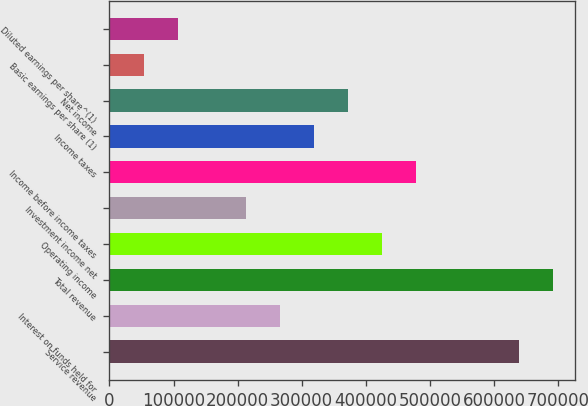<chart> <loc_0><loc_0><loc_500><loc_500><bar_chart><fcel>Service revenue<fcel>Interest on funds held for<fcel>Total revenue<fcel>Operating income<fcel>Investment income net<fcel>Income before income taxes<fcel>Income taxes<fcel>Net income<fcel>Basic earnings per share (1)<fcel>Diluted earnings per share^(1)<nl><fcel>638606<fcel>266086<fcel>691824<fcel>425738<fcel>212869<fcel>478955<fcel>319303<fcel>372520<fcel>53217.5<fcel>106435<nl></chart> 